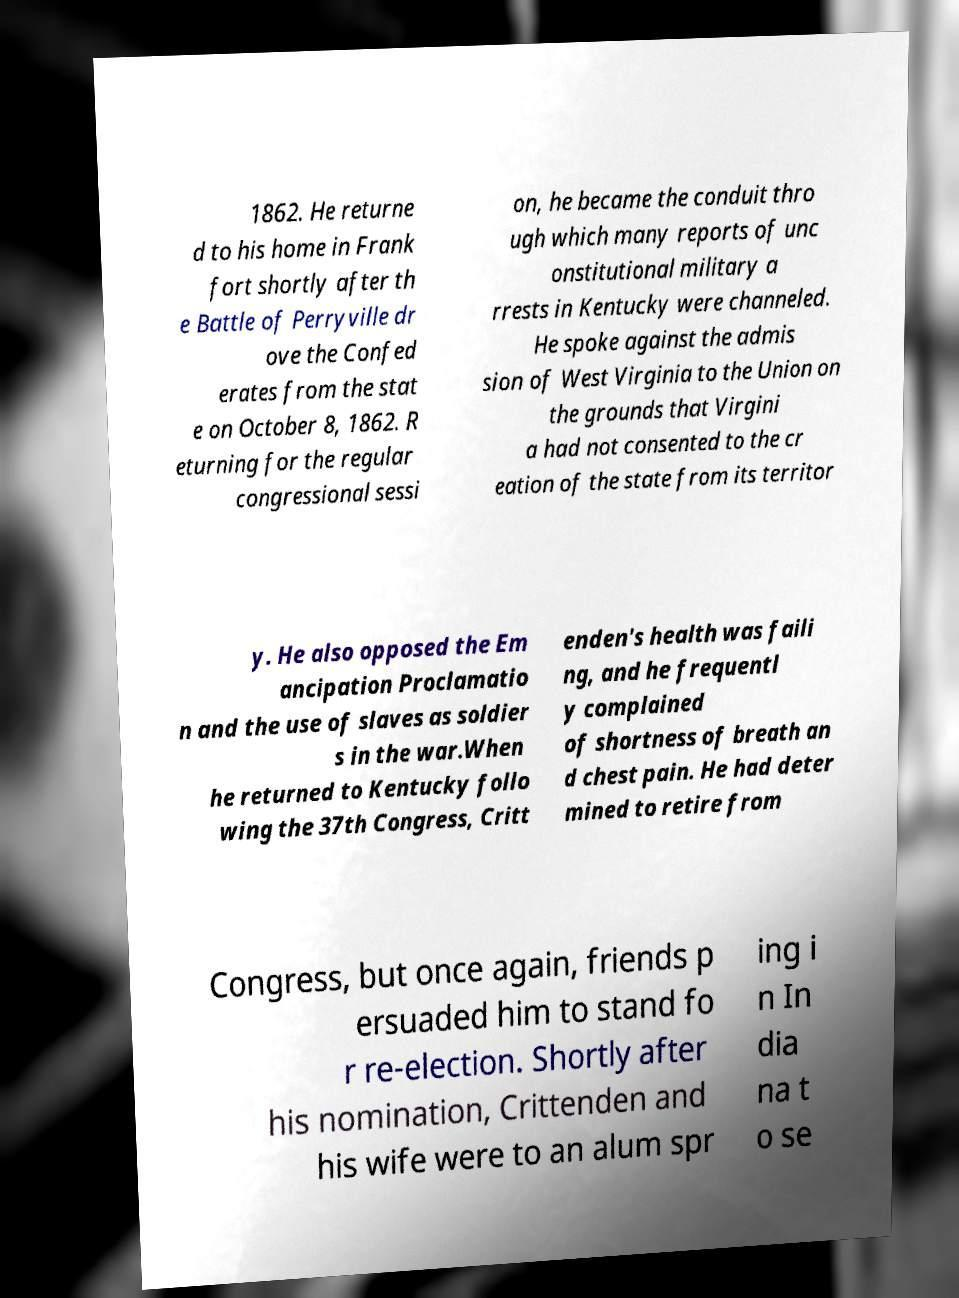For documentation purposes, I need the text within this image transcribed. Could you provide that? 1862. He returne d to his home in Frank fort shortly after th e Battle of Perryville dr ove the Confed erates from the stat e on October 8, 1862. R eturning for the regular congressional sessi on, he became the conduit thro ugh which many reports of unc onstitutional military a rrests in Kentucky were channeled. He spoke against the admis sion of West Virginia to the Union on the grounds that Virgini a had not consented to the cr eation of the state from its territor y. He also opposed the Em ancipation Proclamatio n and the use of slaves as soldier s in the war.When he returned to Kentucky follo wing the 37th Congress, Critt enden's health was faili ng, and he frequentl y complained of shortness of breath an d chest pain. He had deter mined to retire from Congress, but once again, friends p ersuaded him to stand fo r re-election. Shortly after his nomination, Crittenden and his wife were to an alum spr ing i n In dia na t o se 